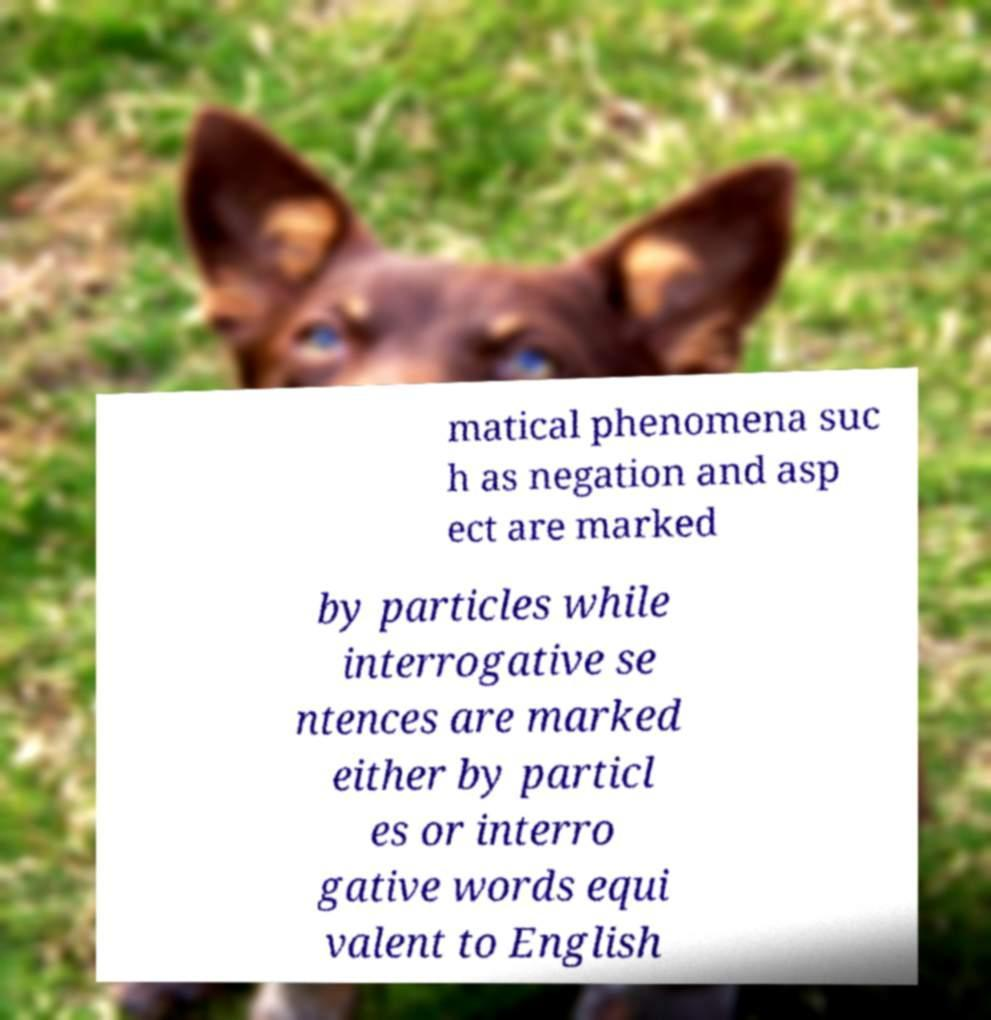Could you extract and type out the text from this image? matical phenomena suc h as negation and asp ect are marked by particles while interrogative se ntences are marked either by particl es or interro gative words equi valent to English 